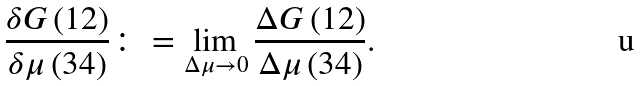Convert formula to latex. <formula><loc_0><loc_0><loc_500><loc_500>\frac { \delta G \left ( 1 2 \right ) } { \delta \mu \left ( 3 4 \right ) } \colon = \lim _ { \Delta \mu \rightarrow 0 } \frac { \Delta G \left ( 1 2 \right ) } { \Delta \mu \left ( 3 4 \right ) } .</formula> 